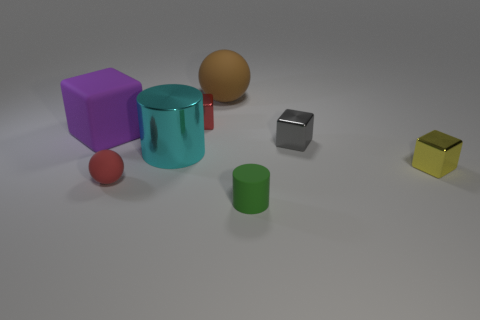What materials do the objects seem to be made of? The objects seem to have various materials. The purple, yellow, and cyan objects have a matte finish suggesting a plastic or painted metal surface, the brown sphere looks like it could be wooden, the silver cuboid seems metallic, and the red sphere has a shiny surface, potentially plastic or polished metal. 